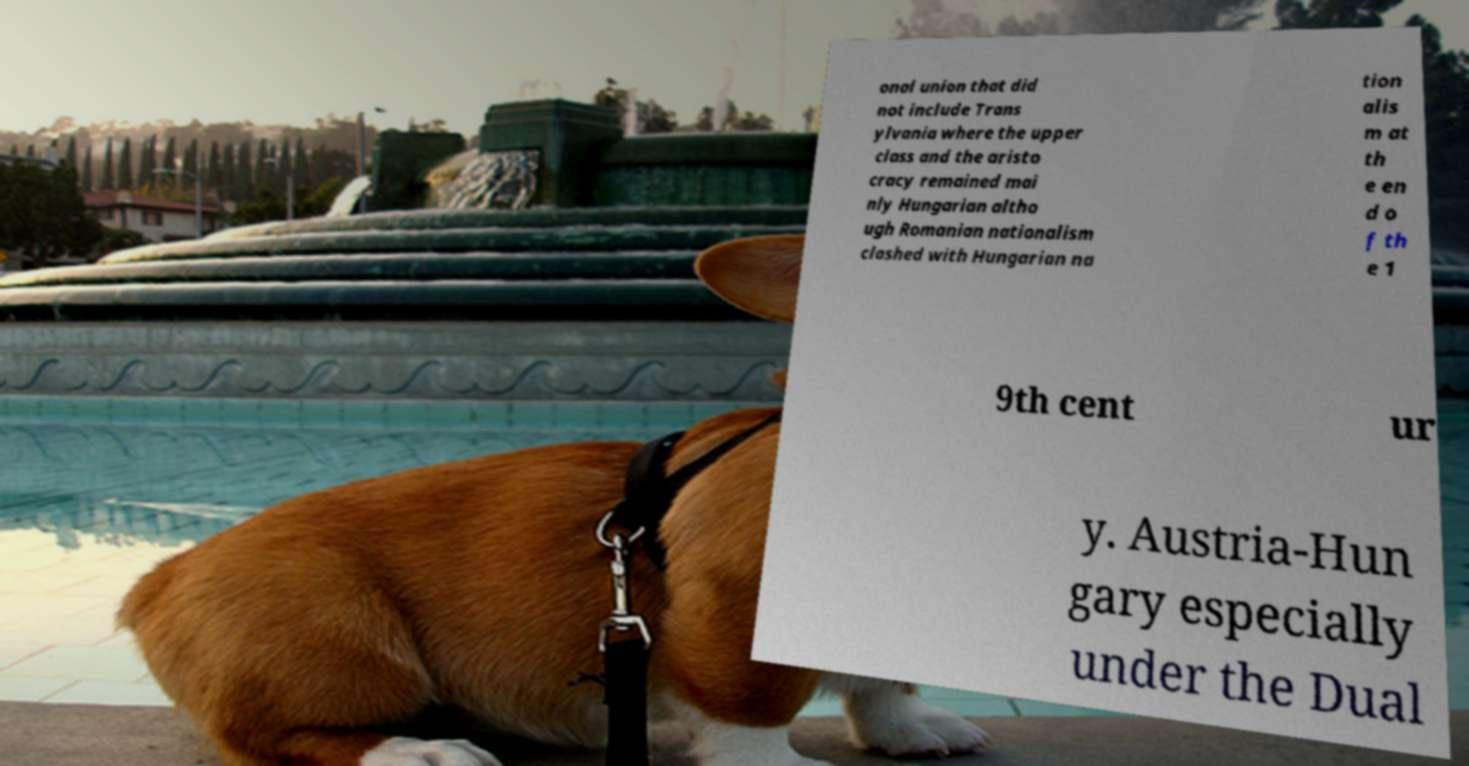Can you accurately transcribe the text from the provided image for me? onal union that did not include Trans ylvania where the upper class and the aristo cracy remained mai nly Hungarian altho ugh Romanian nationalism clashed with Hungarian na tion alis m at th e en d o f th e 1 9th cent ur y. Austria-Hun gary especially under the Dual 